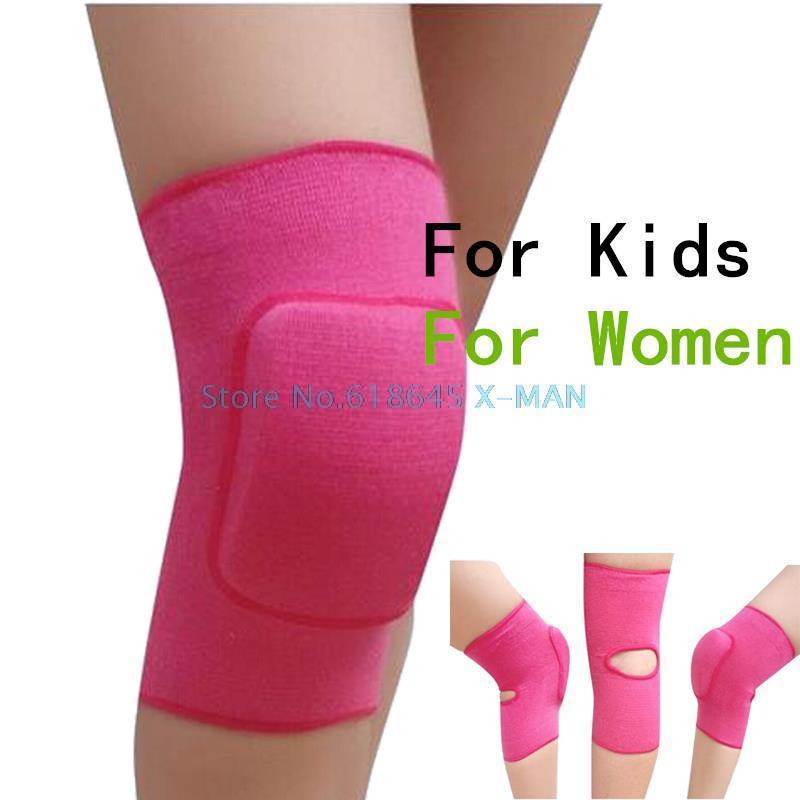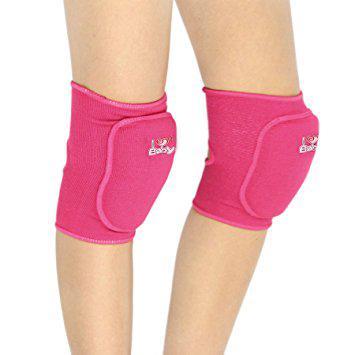The first image is the image on the left, the second image is the image on the right. Considering the images on both sides, is "Each image includes a rightward-bent knee in a hot pink knee pad." valid? Answer yes or no. Yes. 